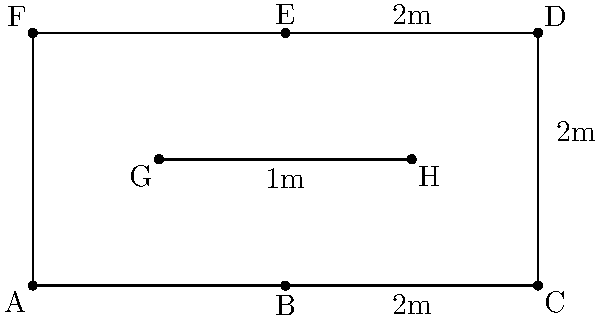A gymnast is performing a complex body position represented by the simplified diagram above. The body is divided into 8 segments (A to H) with equal mass. Calculate the x-coordinate of the center of mass for this body position. Assume the origin (0,0) is at point A, and each grid unit represents 1 meter. To find the x-coordinate of the center of mass, we need to follow these steps:

1) Identify the x-coordinates of each point:
   A(0), F(0), G(1), B(2), E(2), H(3), C(4), D(4)

2) Calculate the average x-coordinate:
   $$x_{CM} = \frac{x_A + x_B + x_C + x_D + x_E + x_F + x_G + x_H}{8}$$

3) Substitute the values:
   $$x_{CM} = \frac{0 + 2 + 4 + 4 + 2 + 0 + 1 + 3}{8}$$

4) Simplify:
   $$x_{CM} = \frac{16}{8} = 2$$

Therefore, the x-coordinate of the center of mass is 2 meters from the origin.
Answer: 2 meters 